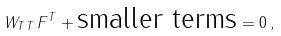Convert formula to latex. <formula><loc_0><loc_0><loc_500><loc_500>W _ { T T } \, F ^ { T } + \text {smaller terms} = 0 \, ,</formula> 